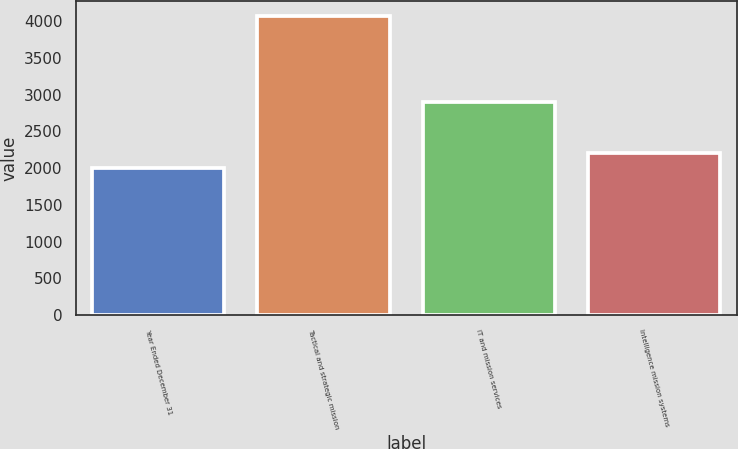Convert chart. <chart><loc_0><loc_0><loc_500><loc_500><bar_chart><fcel>Year Ended December 31<fcel>Tactical and strategic mission<fcel>IT and mission services<fcel>Intelligence mission systems<nl><fcel>2006<fcel>4063<fcel>2894<fcel>2211.7<nl></chart> 